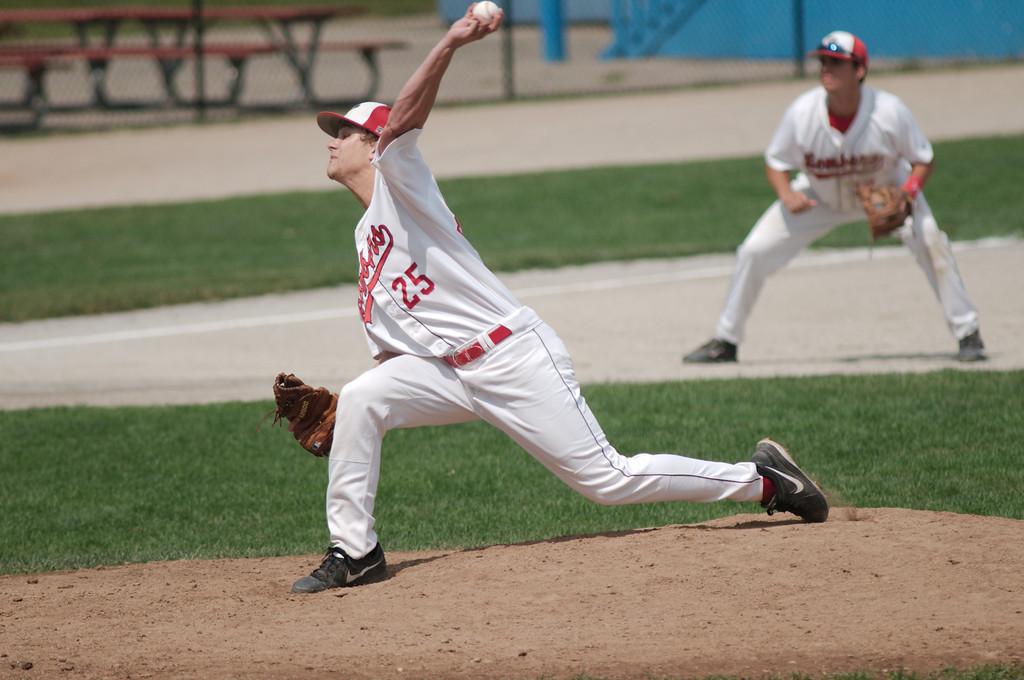What is this player's number?
Make the answer very short. 25. 